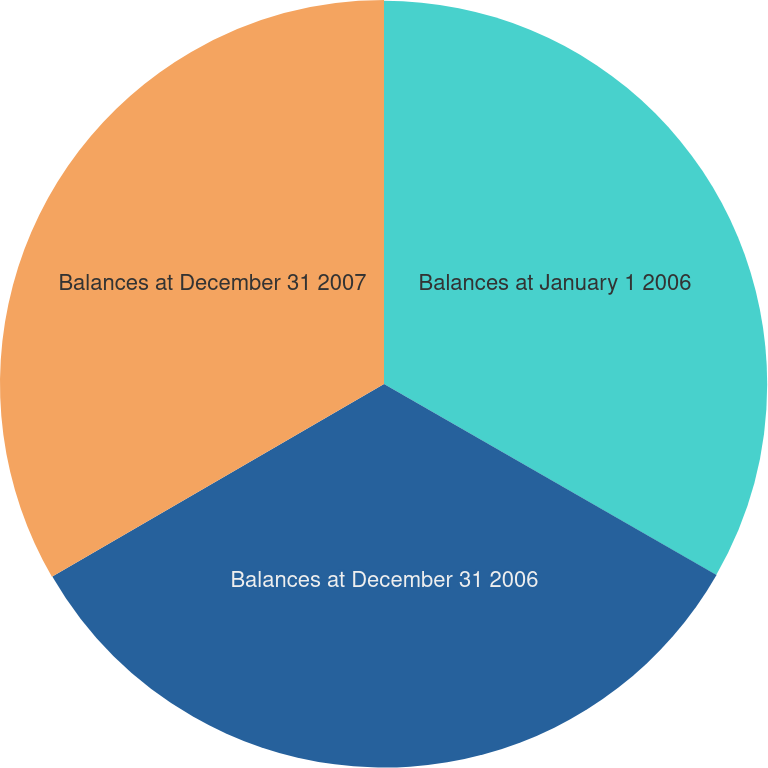Convert chart to OTSL. <chart><loc_0><loc_0><loc_500><loc_500><pie_chart><fcel>Balances at January 1 2006<fcel>Balances at December 31 2006<fcel>Balances at December 31 2007<nl><fcel>33.3%<fcel>33.33%<fcel>33.37%<nl></chart> 